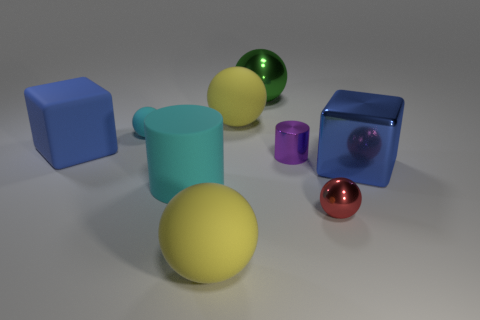There is a thing that is left of the cyan rubber cylinder and on the right side of the large blue matte thing; what material is it?
Keep it short and to the point. Rubber. Does the shiny block have the same color as the rubber object in front of the small red sphere?
Keep it short and to the point. No. There is another sphere that is the same size as the cyan matte sphere; what is it made of?
Ensure brevity in your answer.  Metal. Are there any blue blocks made of the same material as the large cyan cylinder?
Ensure brevity in your answer.  Yes. How many blue balls are there?
Offer a terse response. 0. Is the small red sphere made of the same material as the big blue block behind the small cylinder?
Keep it short and to the point. No. There is a thing that is the same color as the tiny matte ball; what is its material?
Your answer should be compact. Rubber. How many large spheres have the same color as the metallic cylinder?
Your answer should be compact. 0. What is the size of the purple cylinder?
Give a very brief answer. Small. Is the shape of the large green metal object the same as the cyan matte thing that is on the right side of the small cyan ball?
Give a very brief answer. No. 